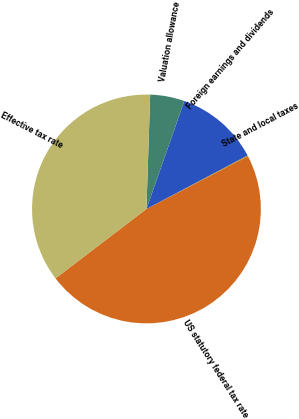Convert chart. <chart><loc_0><loc_0><loc_500><loc_500><pie_chart><fcel>US statutory federal tax rate<fcel>State and local taxes<fcel>Foreign earnings and dividends<fcel>Valuation allowance<fcel>Effective tax rate<nl><fcel>47.24%<fcel>0.13%<fcel>11.88%<fcel>4.85%<fcel>35.9%<nl></chart> 